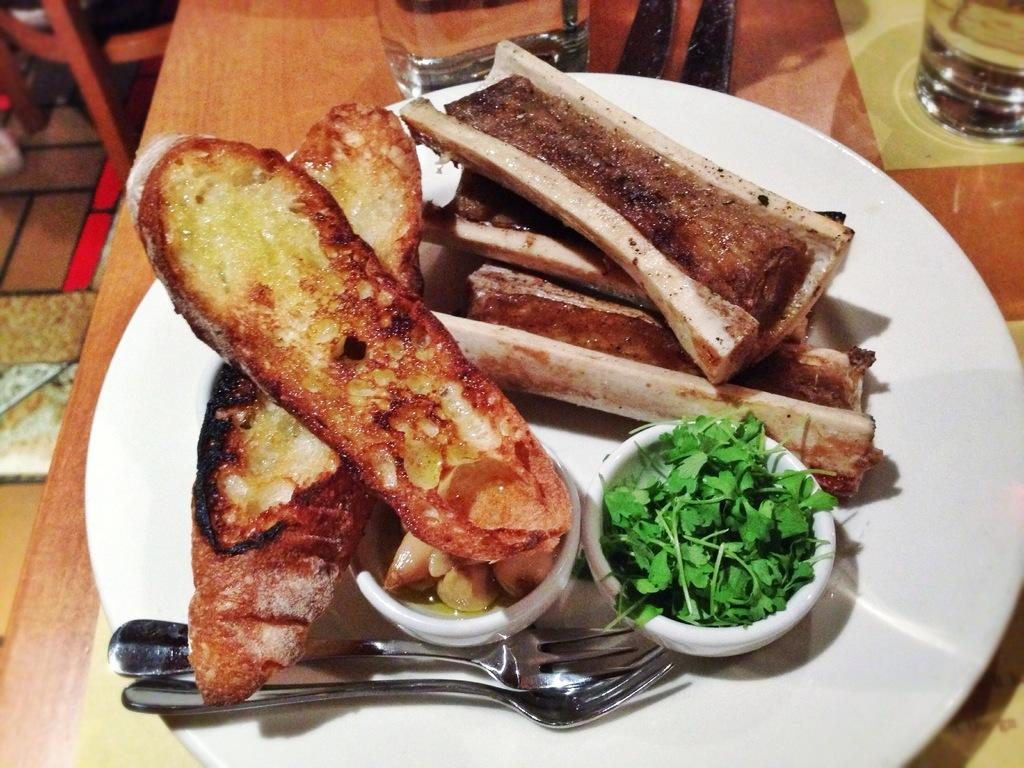What piece of furniture is present in the image? There is a table in the image. What is placed on the table? There is a plate on the table. What can be found on the plate? There are food items on the plate, including vegetables. Are there any utensils on the plate? Yes, there are spoons on the plate. What else is on the plate besides food and utensils? There is a box on the plate. What is the chair's position in the image? There is a chair on the floor. What type of kettle is being used to make tea in the image? There is no kettle present in the image; it only features a table, a plate, food items, spoons, a box, and a chair. 